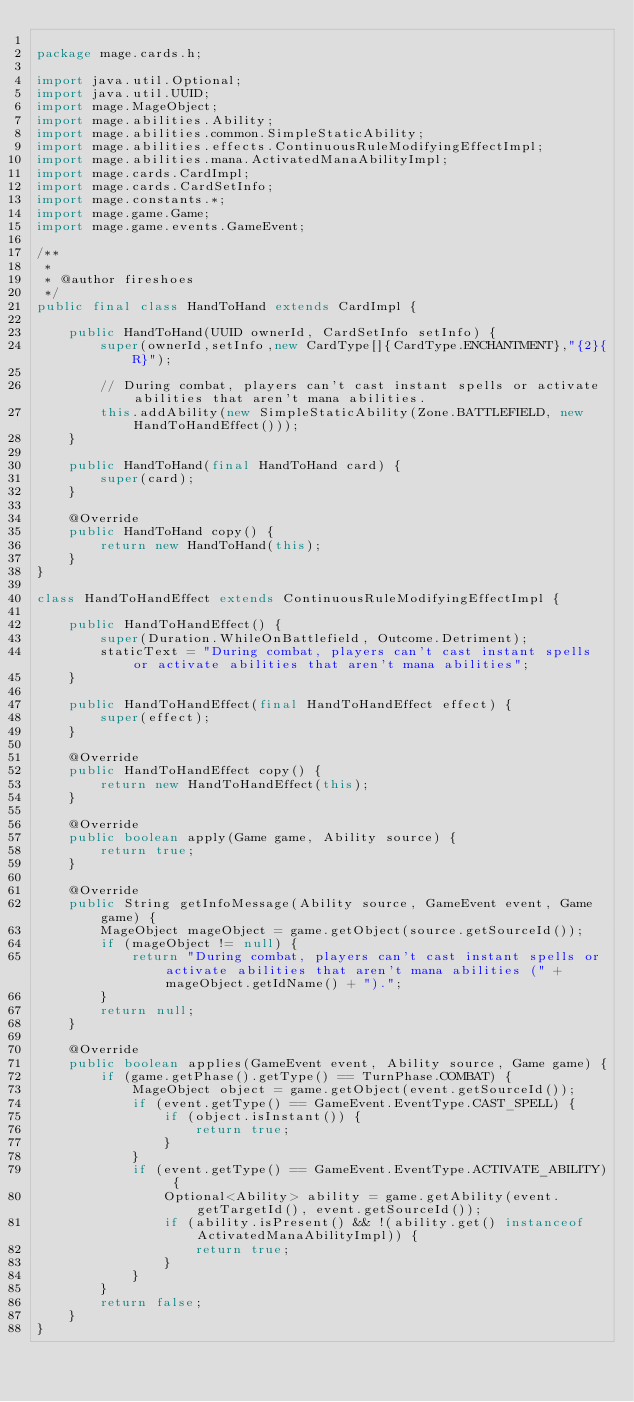<code> <loc_0><loc_0><loc_500><loc_500><_Java_>
package mage.cards.h;

import java.util.Optional;
import java.util.UUID;
import mage.MageObject;
import mage.abilities.Ability;
import mage.abilities.common.SimpleStaticAbility;
import mage.abilities.effects.ContinuousRuleModifyingEffectImpl;
import mage.abilities.mana.ActivatedManaAbilityImpl;
import mage.cards.CardImpl;
import mage.cards.CardSetInfo;
import mage.constants.*;
import mage.game.Game;
import mage.game.events.GameEvent;

/**
 *
 * @author fireshoes
 */
public final class HandToHand extends CardImpl {

    public HandToHand(UUID ownerId, CardSetInfo setInfo) {
        super(ownerId,setInfo,new CardType[]{CardType.ENCHANTMENT},"{2}{R}");

        // During combat, players can't cast instant spells or activate abilities that aren't mana abilities.
        this.addAbility(new SimpleStaticAbility(Zone.BATTLEFIELD, new HandToHandEffect()));
    }

    public HandToHand(final HandToHand card) {
        super(card);
    }

    @Override
    public HandToHand copy() {
        return new HandToHand(this);
    }
}

class HandToHandEffect extends ContinuousRuleModifyingEffectImpl {

    public HandToHandEffect() {
        super(Duration.WhileOnBattlefield, Outcome.Detriment);
        staticText = "During combat, players can't cast instant spells or activate abilities that aren't mana abilities";
    }

    public HandToHandEffect(final HandToHandEffect effect) {
        super(effect);
    }

    @Override
    public HandToHandEffect copy() {
        return new HandToHandEffect(this);
    }

    @Override
    public boolean apply(Game game, Ability source) {
        return true;
    }

    @Override
    public String getInfoMessage(Ability source, GameEvent event, Game game) {
        MageObject mageObject = game.getObject(source.getSourceId());
        if (mageObject != null) {
            return "During combat, players can't cast instant spells or activate abilities that aren't mana abilities (" + mageObject.getIdName() + ").";
        }
        return null;
    }

    @Override
    public boolean applies(GameEvent event, Ability source, Game game) {
        if (game.getPhase().getType() == TurnPhase.COMBAT) {
            MageObject object = game.getObject(event.getSourceId());
            if (event.getType() == GameEvent.EventType.CAST_SPELL) {
                if (object.isInstant()) {
                    return true;
                }
            }
            if (event.getType() == GameEvent.EventType.ACTIVATE_ABILITY) {
                Optional<Ability> ability = game.getAbility(event.getTargetId(), event.getSourceId());
                if (ability.isPresent() && !(ability.get() instanceof ActivatedManaAbilityImpl)) {
                    return true;
                }
            }
        }
        return false;
    }
}
</code> 